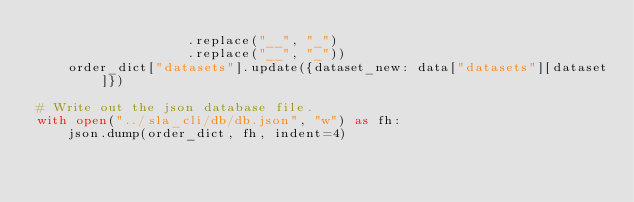Convert code to text. <code><loc_0><loc_0><loc_500><loc_500><_Python_>                   .replace("__", "_")
                   .replace("__", "_"))
    order_dict["datasets"].update({dataset_new: data["datasets"][dataset]})

# Write out the json database file.
with open("../sla_cli/db/db.json", "w") as fh:
    json.dump(order_dict, fh, indent=4)
</code> 